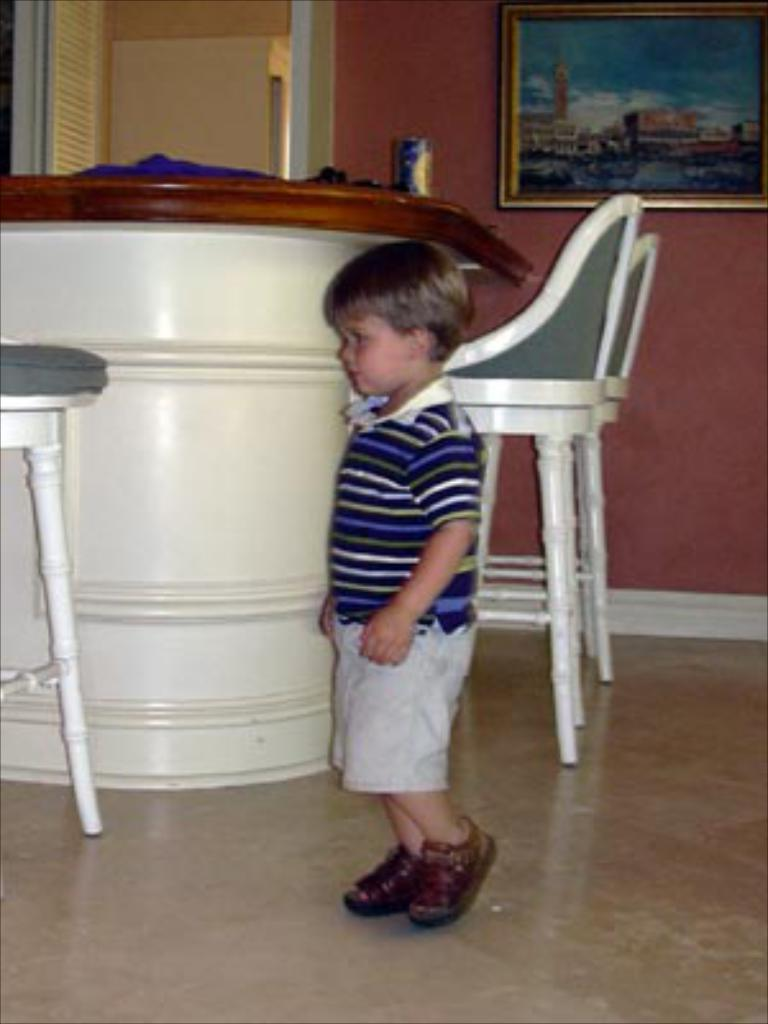What is the main subject of the image? There is a boy standing in the image. How many chairs are visible in the image? There are three chairs in the image. What color is the cloth in the image? There is a purple cloth in the image. What is on the desk in the image? There is a bottle on a desk in the image. What is hanging on the wall in the image? There is a frame on the wall in the image. How many pages are visible in the image? There are no pages present in the image. Is there a tiger in the image? No, there is no tiger in the image. 